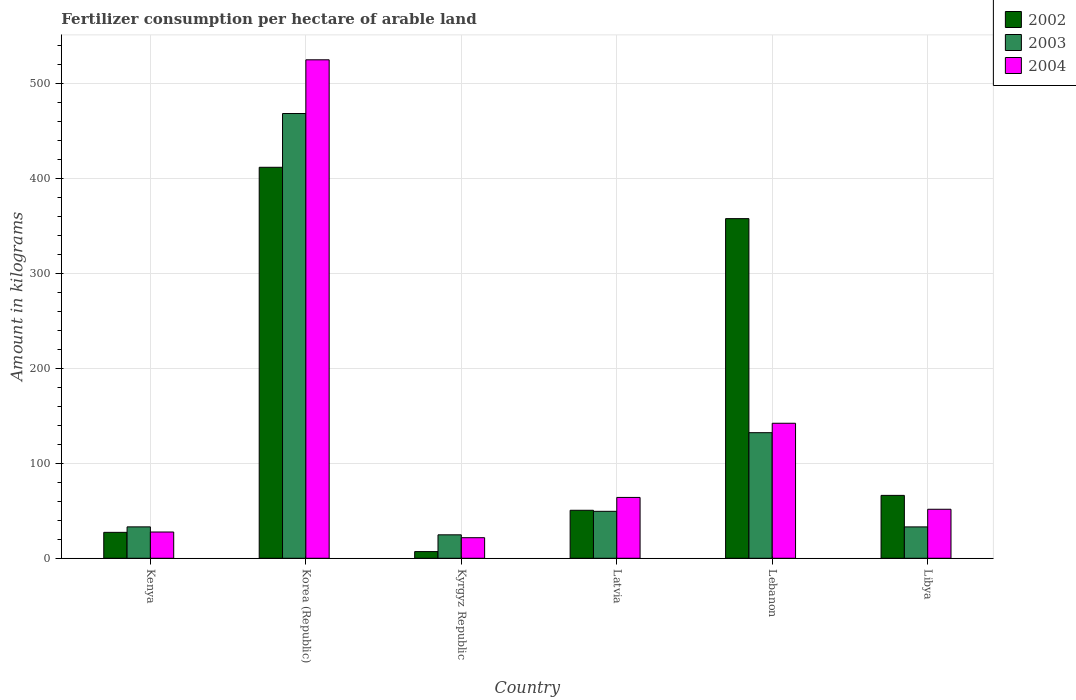How many different coloured bars are there?
Provide a short and direct response. 3. Are the number of bars per tick equal to the number of legend labels?
Offer a terse response. Yes. Are the number of bars on each tick of the X-axis equal?
Make the answer very short. Yes. How many bars are there on the 5th tick from the left?
Provide a succinct answer. 3. What is the label of the 6th group of bars from the left?
Give a very brief answer. Libya. In how many cases, is the number of bars for a given country not equal to the number of legend labels?
Give a very brief answer. 0. What is the amount of fertilizer consumption in 2003 in Kyrgyz Republic?
Offer a terse response. 24.71. Across all countries, what is the maximum amount of fertilizer consumption in 2002?
Offer a very short reply. 412.13. Across all countries, what is the minimum amount of fertilizer consumption in 2003?
Provide a short and direct response. 24.71. In which country was the amount of fertilizer consumption in 2002 minimum?
Give a very brief answer. Kyrgyz Republic. What is the total amount of fertilizer consumption in 2003 in the graph?
Your answer should be very brief. 741.54. What is the difference between the amount of fertilizer consumption in 2004 in Kenya and that in Kyrgyz Republic?
Your response must be concise. 6. What is the difference between the amount of fertilizer consumption in 2003 in Kenya and the amount of fertilizer consumption in 2004 in Korea (Republic)?
Your answer should be very brief. -492.33. What is the average amount of fertilizer consumption in 2004 per country?
Offer a very short reply. 138.81. What is the difference between the amount of fertilizer consumption of/in 2003 and amount of fertilizer consumption of/in 2004 in Kenya?
Your answer should be very brief. 5.42. What is the ratio of the amount of fertilizer consumption in 2002 in Latvia to that in Lebanon?
Ensure brevity in your answer.  0.14. Is the amount of fertilizer consumption in 2003 in Kyrgyz Republic less than that in Libya?
Keep it short and to the point. Yes. What is the difference between the highest and the second highest amount of fertilizer consumption in 2003?
Provide a succinct answer. -336.42. What is the difference between the highest and the lowest amount of fertilizer consumption in 2004?
Give a very brief answer. 503.74. What does the 1st bar from the left in Kyrgyz Republic represents?
Your answer should be very brief. 2002. What does the 2nd bar from the right in Korea (Republic) represents?
Provide a succinct answer. 2003. Is it the case that in every country, the sum of the amount of fertilizer consumption in 2003 and amount of fertilizer consumption in 2002 is greater than the amount of fertilizer consumption in 2004?
Your response must be concise. Yes. How many bars are there?
Your response must be concise. 18. What is the difference between two consecutive major ticks on the Y-axis?
Offer a terse response. 100. Where does the legend appear in the graph?
Give a very brief answer. Top right. How are the legend labels stacked?
Your answer should be compact. Vertical. What is the title of the graph?
Keep it short and to the point. Fertilizer consumption per hectare of arable land. What is the label or title of the X-axis?
Keep it short and to the point. Country. What is the label or title of the Y-axis?
Your answer should be very brief. Amount in kilograms. What is the Amount in kilograms of 2002 in Kenya?
Give a very brief answer. 27.31. What is the Amount in kilograms in 2003 in Kenya?
Your answer should be compact. 33.1. What is the Amount in kilograms in 2004 in Kenya?
Your answer should be compact. 27.68. What is the Amount in kilograms of 2002 in Korea (Republic)?
Provide a succinct answer. 412.13. What is the Amount in kilograms of 2003 in Korea (Republic)?
Provide a short and direct response. 468.79. What is the Amount in kilograms of 2004 in Korea (Republic)?
Your answer should be compact. 525.42. What is the Amount in kilograms of 2002 in Kyrgyz Republic?
Give a very brief answer. 7.05. What is the Amount in kilograms of 2003 in Kyrgyz Republic?
Offer a very short reply. 24.71. What is the Amount in kilograms of 2004 in Kyrgyz Republic?
Your answer should be compact. 21.68. What is the Amount in kilograms in 2002 in Latvia?
Your answer should be compact. 50.6. What is the Amount in kilograms of 2003 in Latvia?
Ensure brevity in your answer.  49.49. What is the Amount in kilograms of 2004 in Latvia?
Your response must be concise. 64.13. What is the Amount in kilograms of 2002 in Lebanon?
Your answer should be compact. 358. What is the Amount in kilograms in 2003 in Lebanon?
Your response must be concise. 132.38. What is the Amount in kilograms of 2004 in Lebanon?
Your answer should be compact. 142.32. What is the Amount in kilograms of 2002 in Libya?
Your response must be concise. 66.29. What is the Amount in kilograms of 2003 in Libya?
Provide a succinct answer. 33.07. What is the Amount in kilograms in 2004 in Libya?
Your answer should be compact. 51.66. Across all countries, what is the maximum Amount in kilograms of 2002?
Give a very brief answer. 412.13. Across all countries, what is the maximum Amount in kilograms in 2003?
Your answer should be compact. 468.79. Across all countries, what is the maximum Amount in kilograms of 2004?
Give a very brief answer. 525.42. Across all countries, what is the minimum Amount in kilograms of 2002?
Provide a short and direct response. 7.05. Across all countries, what is the minimum Amount in kilograms of 2003?
Offer a very short reply. 24.71. Across all countries, what is the minimum Amount in kilograms in 2004?
Provide a succinct answer. 21.68. What is the total Amount in kilograms of 2002 in the graph?
Your response must be concise. 921.38. What is the total Amount in kilograms in 2003 in the graph?
Give a very brief answer. 741.54. What is the total Amount in kilograms in 2004 in the graph?
Give a very brief answer. 832.89. What is the difference between the Amount in kilograms of 2002 in Kenya and that in Korea (Republic)?
Your response must be concise. -384.81. What is the difference between the Amount in kilograms of 2003 in Kenya and that in Korea (Republic)?
Provide a short and direct response. -435.69. What is the difference between the Amount in kilograms in 2004 in Kenya and that in Korea (Republic)?
Your response must be concise. -497.74. What is the difference between the Amount in kilograms of 2002 in Kenya and that in Kyrgyz Republic?
Ensure brevity in your answer.  20.26. What is the difference between the Amount in kilograms in 2003 in Kenya and that in Kyrgyz Republic?
Your response must be concise. 8.39. What is the difference between the Amount in kilograms in 2004 in Kenya and that in Kyrgyz Republic?
Keep it short and to the point. 6. What is the difference between the Amount in kilograms of 2002 in Kenya and that in Latvia?
Provide a short and direct response. -23.28. What is the difference between the Amount in kilograms in 2003 in Kenya and that in Latvia?
Keep it short and to the point. -16.4. What is the difference between the Amount in kilograms of 2004 in Kenya and that in Latvia?
Keep it short and to the point. -36.45. What is the difference between the Amount in kilograms in 2002 in Kenya and that in Lebanon?
Offer a terse response. -330.69. What is the difference between the Amount in kilograms of 2003 in Kenya and that in Lebanon?
Make the answer very short. -99.28. What is the difference between the Amount in kilograms of 2004 in Kenya and that in Lebanon?
Ensure brevity in your answer.  -114.64. What is the difference between the Amount in kilograms of 2002 in Kenya and that in Libya?
Make the answer very short. -38.98. What is the difference between the Amount in kilograms in 2003 in Kenya and that in Libya?
Offer a terse response. 0.03. What is the difference between the Amount in kilograms in 2004 in Kenya and that in Libya?
Your answer should be compact. -23.98. What is the difference between the Amount in kilograms in 2002 in Korea (Republic) and that in Kyrgyz Republic?
Your answer should be very brief. 405.08. What is the difference between the Amount in kilograms of 2003 in Korea (Republic) and that in Kyrgyz Republic?
Your response must be concise. 444.08. What is the difference between the Amount in kilograms of 2004 in Korea (Republic) and that in Kyrgyz Republic?
Provide a succinct answer. 503.74. What is the difference between the Amount in kilograms of 2002 in Korea (Republic) and that in Latvia?
Provide a succinct answer. 361.53. What is the difference between the Amount in kilograms in 2003 in Korea (Republic) and that in Latvia?
Provide a short and direct response. 419.3. What is the difference between the Amount in kilograms of 2004 in Korea (Republic) and that in Latvia?
Offer a terse response. 461.29. What is the difference between the Amount in kilograms of 2002 in Korea (Republic) and that in Lebanon?
Offer a very short reply. 54.13. What is the difference between the Amount in kilograms in 2003 in Korea (Republic) and that in Lebanon?
Your answer should be very brief. 336.42. What is the difference between the Amount in kilograms in 2004 in Korea (Republic) and that in Lebanon?
Offer a very short reply. 383.1. What is the difference between the Amount in kilograms of 2002 in Korea (Republic) and that in Libya?
Provide a succinct answer. 345.84. What is the difference between the Amount in kilograms in 2003 in Korea (Republic) and that in Libya?
Your answer should be compact. 435.72. What is the difference between the Amount in kilograms of 2004 in Korea (Republic) and that in Libya?
Your answer should be compact. 473.77. What is the difference between the Amount in kilograms of 2002 in Kyrgyz Republic and that in Latvia?
Ensure brevity in your answer.  -43.54. What is the difference between the Amount in kilograms of 2003 in Kyrgyz Republic and that in Latvia?
Your answer should be very brief. -24.78. What is the difference between the Amount in kilograms of 2004 in Kyrgyz Republic and that in Latvia?
Give a very brief answer. -42.45. What is the difference between the Amount in kilograms of 2002 in Kyrgyz Republic and that in Lebanon?
Offer a very short reply. -350.95. What is the difference between the Amount in kilograms of 2003 in Kyrgyz Republic and that in Lebanon?
Provide a succinct answer. -107.66. What is the difference between the Amount in kilograms in 2004 in Kyrgyz Republic and that in Lebanon?
Your response must be concise. -120.64. What is the difference between the Amount in kilograms of 2002 in Kyrgyz Republic and that in Libya?
Your answer should be very brief. -59.24. What is the difference between the Amount in kilograms in 2003 in Kyrgyz Republic and that in Libya?
Your answer should be very brief. -8.36. What is the difference between the Amount in kilograms in 2004 in Kyrgyz Republic and that in Libya?
Give a very brief answer. -29.97. What is the difference between the Amount in kilograms in 2002 in Latvia and that in Lebanon?
Provide a succinct answer. -307.4. What is the difference between the Amount in kilograms in 2003 in Latvia and that in Lebanon?
Provide a short and direct response. -82.88. What is the difference between the Amount in kilograms of 2004 in Latvia and that in Lebanon?
Make the answer very short. -78.19. What is the difference between the Amount in kilograms in 2002 in Latvia and that in Libya?
Keep it short and to the point. -15.7. What is the difference between the Amount in kilograms in 2003 in Latvia and that in Libya?
Your response must be concise. 16.42. What is the difference between the Amount in kilograms in 2004 in Latvia and that in Libya?
Make the answer very short. 12.47. What is the difference between the Amount in kilograms in 2002 in Lebanon and that in Libya?
Make the answer very short. 291.71. What is the difference between the Amount in kilograms in 2003 in Lebanon and that in Libya?
Keep it short and to the point. 99.31. What is the difference between the Amount in kilograms of 2004 in Lebanon and that in Libya?
Offer a terse response. 90.66. What is the difference between the Amount in kilograms in 2002 in Kenya and the Amount in kilograms in 2003 in Korea (Republic)?
Give a very brief answer. -441.48. What is the difference between the Amount in kilograms in 2002 in Kenya and the Amount in kilograms in 2004 in Korea (Republic)?
Your answer should be compact. -498.11. What is the difference between the Amount in kilograms of 2003 in Kenya and the Amount in kilograms of 2004 in Korea (Republic)?
Provide a short and direct response. -492.33. What is the difference between the Amount in kilograms in 2002 in Kenya and the Amount in kilograms in 2003 in Kyrgyz Republic?
Make the answer very short. 2.6. What is the difference between the Amount in kilograms in 2002 in Kenya and the Amount in kilograms in 2004 in Kyrgyz Republic?
Offer a very short reply. 5.63. What is the difference between the Amount in kilograms in 2003 in Kenya and the Amount in kilograms in 2004 in Kyrgyz Republic?
Offer a terse response. 11.41. What is the difference between the Amount in kilograms in 2002 in Kenya and the Amount in kilograms in 2003 in Latvia?
Your answer should be compact. -22.18. What is the difference between the Amount in kilograms of 2002 in Kenya and the Amount in kilograms of 2004 in Latvia?
Your answer should be compact. -36.82. What is the difference between the Amount in kilograms in 2003 in Kenya and the Amount in kilograms in 2004 in Latvia?
Your answer should be very brief. -31.03. What is the difference between the Amount in kilograms in 2002 in Kenya and the Amount in kilograms in 2003 in Lebanon?
Give a very brief answer. -105.06. What is the difference between the Amount in kilograms of 2002 in Kenya and the Amount in kilograms of 2004 in Lebanon?
Offer a very short reply. -115.01. What is the difference between the Amount in kilograms in 2003 in Kenya and the Amount in kilograms in 2004 in Lebanon?
Offer a terse response. -109.22. What is the difference between the Amount in kilograms in 2002 in Kenya and the Amount in kilograms in 2003 in Libya?
Ensure brevity in your answer.  -5.76. What is the difference between the Amount in kilograms in 2002 in Kenya and the Amount in kilograms in 2004 in Libya?
Ensure brevity in your answer.  -24.34. What is the difference between the Amount in kilograms of 2003 in Kenya and the Amount in kilograms of 2004 in Libya?
Your response must be concise. -18.56. What is the difference between the Amount in kilograms in 2002 in Korea (Republic) and the Amount in kilograms in 2003 in Kyrgyz Republic?
Offer a very short reply. 387.42. What is the difference between the Amount in kilograms in 2002 in Korea (Republic) and the Amount in kilograms in 2004 in Kyrgyz Republic?
Give a very brief answer. 390.45. What is the difference between the Amount in kilograms in 2003 in Korea (Republic) and the Amount in kilograms in 2004 in Kyrgyz Republic?
Give a very brief answer. 447.11. What is the difference between the Amount in kilograms of 2002 in Korea (Republic) and the Amount in kilograms of 2003 in Latvia?
Offer a very short reply. 362.63. What is the difference between the Amount in kilograms of 2002 in Korea (Republic) and the Amount in kilograms of 2004 in Latvia?
Give a very brief answer. 348. What is the difference between the Amount in kilograms in 2003 in Korea (Republic) and the Amount in kilograms in 2004 in Latvia?
Provide a succinct answer. 404.66. What is the difference between the Amount in kilograms in 2002 in Korea (Republic) and the Amount in kilograms in 2003 in Lebanon?
Your response must be concise. 279.75. What is the difference between the Amount in kilograms in 2002 in Korea (Republic) and the Amount in kilograms in 2004 in Lebanon?
Offer a very short reply. 269.81. What is the difference between the Amount in kilograms in 2003 in Korea (Republic) and the Amount in kilograms in 2004 in Lebanon?
Your answer should be very brief. 326.47. What is the difference between the Amount in kilograms of 2002 in Korea (Republic) and the Amount in kilograms of 2003 in Libya?
Provide a succinct answer. 379.06. What is the difference between the Amount in kilograms in 2002 in Korea (Republic) and the Amount in kilograms in 2004 in Libya?
Your answer should be very brief. 360.47. What is the difference between the Amount in kilograms of 2003 in Korea (Republic) and the Amount in kilograms of 2004 in Libya?
Your answer should be very brief. 417.13. What is the difference between the Amount in kilograms of 2002 in Kyrgyz Republic and the Amount in kilograms of 2003 in Latvia?
Provide a short and direct response. -42.44. What is the difference between the Amount in kilograms of 2002 in Kyrgyz Republic and the Amount in kilograms of 2004 in Latvia?
Keep it short and to the point. -57.08. What is the difference between the Amount in kilograms of 2003 in Kyrgyz Republic and the Amount in kilograms of 2004 in Latvia?
Give a very brief answer. -39.42. What is the difference between the Amount in kilograms of 2002 in Kyrgyz Republic and the Amount in kilograms of 2003 in Lebanon?
Your answer should be compact. -125.32. What is the difference between the Amount in kilograms of 2002 in Kyrgyz Republic and the Amount in kilograms of 2004 in Lebanon?
Your answer should be compact. -135.27. What is the difference between the Amount in kilograms in 2003 in Kyrgyz Republic and the Amount in kilograms in 2004 in Lebanon?
Your answer should be compact. -117.61. What is the difference between the Amount in kilograms of 2002 in Kyrgyz Republic and the Amount in kilograms of 2003 in Libya?
Offer a very short reply. -26.02. What is the difference between the Amount in kilograms in 2002 in Kyrgyz Republic and the Amount in kilograms in 2004 in Libya?
Keep it short and to the point. -44.61. What is the difference between the Amount in kilograms in 2003 in Kyrgyz Republic and the Amount in kilograms in 2004 in Libya?
Make the answer very short. -26.95. What is the difference between the Amount in kilograms of 2002 in Latvia and the Amount in kilograms of 2003 in Lebanon?
Your response must be concise. -81.78. What is the difference between the Amount in kilograms in 2002 in Latvia and the Amount in kilograms in 2004 in Lebanon?
Your answer should be compact. -91.72. What is the difference between the Amount in kilograms in 2003 in Latvia and the Amount in kilograms in 2004 in Lebanon?
Give a very brief answer. -92.82. What is the difference between the Amount in kilograms of 2002 in Latvia and the Amount in kilograms of 2003 in Libya?
Your answer should be compact. 17.53. What is the difference between the Amount in kilograms in 2002 in Latvia and the Amount in kilograms in 2004 in Libya?
Offer a very short reply. -1.06. What is the difference between the Amount in kilograms of 2003 in Latvia and the Amount in kilograms of 2004 in Libya?
Your response must be concise. -2.16. What is the difference between the Amount in kilograms in 2002 in Lebanon and the Amount in kilograms in 2003 in Libya?
Ensure brevity in your answer.  324.93. What is the difference between the Amount in kilograms in 2002 in Lebanon and the Amount in kilograms in 2004 in Libya?
Keep it short and to the point. 306.34. What is the difference between the Amount in kilograms of 2003 in Lebanon and the Amount in kilograms of 2004 in Libya?
Ensure brevity in your answer.  80.72. What is the average Amount in kilograms in 2002 per country?
Keep it short and to the point. 153.56. What is the average Amount in kilograms of 2003 per country?
Give a very brief answer. 123.59. What is the average Amount in kilograms of 2004 per country?
Your answer should be compact. 138.81. What is the difference between the Amount in kilograms of 2002 and Amount in kilograms of 2003 in Kenya?
Your answer should be compact. -5.78. What is the difference between the Amount in kilograms in 2002 and Amount in kilograms in 2004 in Kenya?
Offer a very short reply. -0.37. What is the difference between the Amount in kilograms in 2003 and Amount in kilograms in 2004 in Kenya?
Provide a short and direct response. 5.42. What is the difference between the Amount in kilograms of 2002 and Amount in kilograms of 2003 in Korea (Republic)?
Provide a short and direct response. -56.66. What is the difference between the Amount in kilograms of 2002 and Amount in kilograms of 2004 in Korea (Republic)?
Make the answer very short. -113.3. What is the difference between the Amount in kilograms in 2003 and Amount in kilograms in 2004 in Korea (Republic)?
Provide a short and direct response. -56.63. What is the difference between the Amount in kilograms in 2002 and Amount in kilograms in 2003 in Kyrgyz Republic?
Keep it short and to the point. -17.66. What is the difference between the Amount in kilograms of 2002 and Amount in kilograms of 2004 in Kyrgyz Republic?
Your answer should be very brief. -14.63. What is the difference between the Amount in kilograms in 2003 and Amount in kilograms in 2004 in Kyrgyz Republic?
Provide a succinct answer. 3.03. What is the difference between the Amount in kilograms of 2002 and Amount in kilograms of 2003 in Latvia?
Give a very brief answer. 1.1. What is the difference between the Amount in kilograms of 2002 and Amount in kilograms of 2004 in Latvia?
Offer a terse response. -13.53. What is the difference between the Amount in kilograms of 2003 and Amount in kilograms of 2004 in Latvia?
Provide a short and direct response. -14.63. What is the difference between the Amount in kilograms of 2002 and Amount in kilograms of 2003 in Lebanon?
Your answer should be compact. 225.62. What is the difference between the Amount in kilograms in 2002 and Amount in kilograms in 2004 in Lebanon?
Make the answer very short. 215.68. What is the difference between the Amount in kilograms of 2003 and Amount in kilograms of 2004 in Lebanon?
Your response must be concise. -9.94. What is the difference between the Amount in kilograms of 2002 and Amount in kilograms of 2003 in Libya?
Give a very brief answer. 33.22. What is the difference between the Amount in kilograms of 2002 and Amount in kilograms of 2004 in Libya?
Offer a very short reply. 14.64. What is the difference between the Amount in kilograms of 2003 and Amount in kilograms of 2004 in Libya?
Give a very brief answer. -18.59. What is the ratio of the Amount in kilograms of 2002 in Kenya to that in Korea (Republic)?
Make the answer very short. 0.07. What is the ratio of the Amount in kilograms of 2003 in Kenya to that in Korea (Republic)?
Your answer should be compact. 0.07. What is the ratio of the Amount in kilograms in 2004 in Kenya to that in Korea (Republic)?
Provide a succinct answer. 0.05. What is the ratio of the Amount in kilograms in 2002 in Kenya to that in Kyrgyz Republic?
Offer a terse response. 3.87. What is the ratio of the Amount in kilograms in 2003 in Kenya to that in Kyrgyz Republic?
Your answer should be compact. 1.34. What is the ratio of the Amount in kilograms in 2004 in Kenya to that in Kyrgyz Republic?
Your response must be concise. 1.28. What is the ratio of the Amount in kilograms in 2002 in Kenya to that in Latvia?
Your response must be concise. 0.54. What is the ratio of the Amount in kilograms in 2003 in Kenya to that in Latvia?
Give a very brief answer. 0.67. What is the ratio of the Amount in kilograms of 2004 in Kenya to that in Latvia?
Ensure brevity in your answer.  0.43. What is the ratio of the Amount in kilograms of 2002 in Kenya to that in Lebanon?
Give a very brief answer. 0.08. What is the ratio of the Amount in kilograms in 2004 in Kenya to that in Lebanon?
Provide a succinct answer. 0.19. What is the ratio of the Amount in kilograms in 2002 in Kenya to that in Libya?
Keep it short and to the point. 0.41. What is the ratio of the Amount in kilograms of 2004 in Kenya to that in Libya?
Your answer should be compact. 0.54. What is the ratio of the Amount in kilograms in 2002 in Korea (Republic) to that in Kyrgyz Republic?
Offer a very short reply. 58.45. What is the ratio of the Amount in kilograms in 2003 in Korea (Republic) to that in Kyrgyz Republic?
Provide a succinct answer. 18.97. What is the ratio of the Amount in kilograms in 2004 in Korea (Republic) to that in Kyrgyz Republic?
Provide a short and direct response. 24.23. What is the ratio of the Amount in kilograms of 2002 in Korea (Republic) to that in Latvia?
Your response must be concise. 8.15. What is the ratio of the Amount in kilograms of 2003 in Korea (Republic) to that in Latvia?
Offer a very short reply. 9.47. What is the ratio of the Amount in kilograms of 2004 in Korea (Republic) to that in Latvia?
Offer a very short reply. 8.19. What is the ratio of the Amount in kilograms in 2002 in Korea (Republic) to that in Lebanon?
Give a very brief answer. 1.15. What is the ratio of the Amount in kilograms in 2003 in Korea (Republic) to that in Lebanon?
Give a very brief answer. 3.54. What is the ratio of the Amount in kilograms of 2004 in Korea (Republic) to that in Lebanon?
Provide a succinct answer. 3.69. What is the ratio of the Amount in kilograms of 2002 in Korea (Republic) to that in Libya?
Provide a succinct answer. 6.22. What is the ratio of the Amount in kilograms in 2003 in Korea (Republic) to that in Libya?
Your answer should be compact. 14.18. What is the ratio of the Amount in kilograms of 2004 in Korea (Republic) to that in Libya?
Give a very brief answer. 10.17. What is the ratio of the Amount in kilograms of 2002 in Kyrgyz Republic to that in Latvia?
Keep it short and to the point. 0.14. What is the ratio of the Amount in kilograms in 2003 in Kyrgyz Republic to that in Latvia?
Your answer should be compact. 0.5. What is the ratio of the Amount in kilograms of 2004 in Kyrgyz Republic to that in Latvia?
Offer a terse response. 0.34. What is the ratio of the Amount in kilograms of 2002 in Kyrgyz Republic to that in Lebanon?
Keep it short and to the point. 0.02. What is the ratio of the Amount in kilograms in 2003 in Kyrgyz Republic to that in Lebanon?
Make the answer very short. 0.19. What is the ratio of the Amount in kilograms in 2004 in Kyrgyz Republic to that in Lebanon?
Keep it short and to the point. 0.15. What is the ratio of the Amount in kilograms in 2002 in Kyrgyz Republic to that in Libya?
Ensure brevity in your answer.  0.11. What is the ratio of the Amount in kilograms of 2003 in Kyrgyz Republic to that in Libya?
Offer a terse response. 0.75. What is the ratio of the Amount in kilograms in 2004 in Kyrgyz Republic to that in Libya?
Offer a terse response. 0.42. What is the ratio of the Amount in kilograms of 2002 in Latvia to that in Lebanon?
Your answer should be very brief. 0.14. What is the ratio of the Amount in kilograms of 2003 in Latvia to that in Lebanon?
Keep it short and to the point. 0.37. What is the ratio of the Amount in kilograms in 2004 in Latvia to that in Lebanon?
Your answer should be compact. 0.45. What is the ratio of the Amount in kilograms in 2002 in Latvia to that in Libya?
Your answer should be very brief. 0.76. What is the ratio of the Amount in kilograms of 2003 in Latvia to that in Libya?
Your answer should be very brief. 1.5. What is the ratio of the Amount in kilograms in 2004 in Latvia to that in Libya?
Make the answer very short. 1.24. What is the ratio of the Amount in kilograms in 2002 in Lebanon to that in Libya?
Provide a short and direct response. 5.4. What is the ratio of the Amount in kilograms in 2003 in Lebanon to that in Libya?
Offer a terse response. 4. What is the ratio of the Amount in kilograms in 2004 in Lebanon to that in Libya?
Make the answer very short. 2.76. What is the difference between the highest and the second highest Amount in kilograms of 2002?
Provide a short and direct response. 54.13. What is the difference between the highest and the second highest Amount in kilograms in 2003?
Provide a succinct answer. 336.42. What is the difference between the highest and the second highest Amount in kilograms of 2004?
Provide a succinct answer. 383.1. What is the difference between the highest and the lowest Amount in kilograms in 2002?
Ensure brevity in your answer.  405.08. What is the difference between the highest and the lowest Amount in kilograms in 2003?
Give a very brief answer. 444.08. What is the difference between the highest and the lowest Amount in kilograms of 2004?
Provide a short and direct response. 503.74. 